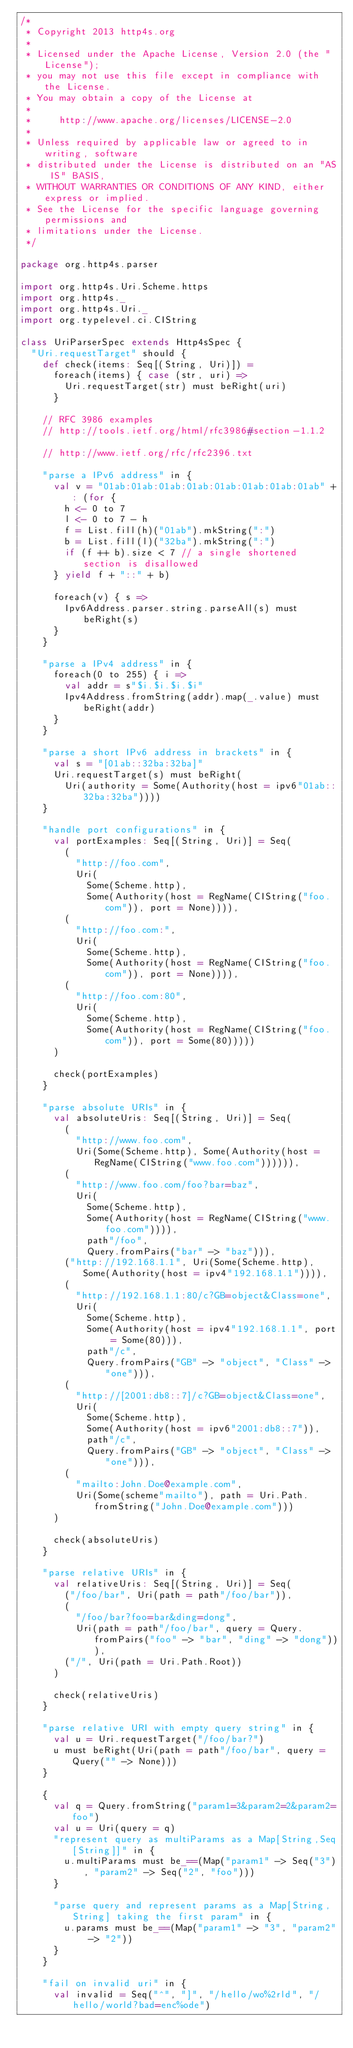<code> <loc_0><loc_0><loc_500><loc_500><_Scala_>/*
 * Copyright 2013 http4s.org
 *
 * Licensed under the Apache License, Version 2.0 (the "License");
 * you may not use this file except in compliance with the License.
 * You may obtain a copy of the License at
 *
 *     http://www.apache.org/licenses/LICENSE-2.0
 *
 * Unless required by applicable law or agreed to in writing, software
 * distributed under the License is distributed on an "AS IS" BASIS,
 * WITHOUT WARRANTIES OR CONDITIONS OF ANY KIND, either express or implied.
 * See the License for the specific language governing permissions and
 * limitations under the License.
 */

package org.http4s.parser

import org.http4s.Uri.Scheme.https
import org.http4s._
import org.http4s.Uri._
import org.typelevel.ci.CIString

class UriParserSpec extends Http4sSpec {
  "Uri.requestTarget" should {
    def check(items: Seq[(String, Uri)]) =
      foreach(items) { case (str, uri) =>
        Uri.requestTarget(str) must beRight(uri)
      }

    // RFC 3986 examples
    // http://tools.ietf.org/html/rfc3986#section-1.1.2

    // http://www.ietf.org/rfc/rfc2396.txt

    "parse a IPv6 address" in {
      val v = "01ab:01ab:01ab:01ab:01ab:01ab:01ab:01ab" +: (for {
        h <- 0 to 7
        l <- 0 to 7 - h
        f = List.fill(h)("01ab").mkString(":")
        b = List.fill(l)("32ba").mkString(":")
        if (f ++ b).size < 7 // a single shortened section is disallowed
      } yield f + "::" + b)

      foreach(v) { s =>
        Ipv6Address.parser.string.parseAll(s) must beRight(s)
      }
    }

    "parse a IPv4 address" in {
      foreach(0 to 255) { i =>
        val addr = s"$i.$i.$i.$i"
        Ipv4Address.fromString(addr).map(_.value) must beRight(addr)
      }
    }

    "parse a short IPv6 address in brackets" in {
      val s = "[01ab::32ba:32ba]"
      Uri.requestTarget(s) must beRight(
        Uri(authority = Some(Authority(host = ipv6"01ab::32ba:32ba"))))
    }

    "handle port configurations" in {
      val portExamples: Seq[(String, Uri)] = Seq(
        (
          "http://foo.com",
          Uri(
            Some(Scheme.http),
            Some(Authority(host = RegName(CIString("foo.com")), port = None)))),
        (
          "http://foo.com:",
          Uri(
            Some(Scheme.http),
            Some(Authority(host = RegName(CIString("foo.com")), port = None)))),
        (
          "http://foo.com:80",
          Uri(
            Some(Scheme.http),
            Some(Authority(host = RegName(CIString("foo.com")), port = Some(80)))))
      )

      check(portExamples)
    }

    "parse absolute URIs" in {
      val absoluteUris: Seq[(String, Uri)] = Seq(
        (
          "http://www.foo.com",
          Uri(Some(Scheme.http), Some(Authority(host = RegName(CIString("www.foo.com")))))),
        (
          "http://www.foo.com/foo?bar=baz",
          Uri(
            Some(Scheme.http),
            Some(Authority(host = RegName(CIString("www.foo.com")))),
            path"/foo",
            Query.fromPairs("bar" -> "baz"))),
        ("http://192.168.1.1", Uri(Some(Scheme.http), Some(Authority(host = ipv4"192.168.1.1")))),
        (
          "http://192.168.1.1:80/c?GB=object&Class=one",
          Uri(
            Some(Scheme.http),
            Some(Authority(host = ipv4"192.168.1.1", port = Some(80))),
            path"/c",
            Query.fromPairs("GB" -> "object", "Class" -> "one"))),
        (
          "http://[2001:db8::7]/c?GB=object&Class=one",
          Uri(
            Some(Scheme.http),
            Some(Authority(host = ipv6"2001:db8::7")),
            path"/c",
            Query.fromPairs("GB" -> "object", "Class" -> "one"))),
        (
          "mailto:John.Doe@example.com",
          Uri(Some(scheme"mailto"), path = Uri.Path.fromString("John.Doe@example.com")))
      )

      check(absoluteUris)
    }

    "parse relative URIs" in {
      val relativeUris: Seq[(String, Uri)] = Seq(
        ("/foo/bar", Uri(path = path"/foo/bar")),
        (
          "/foo/bar?foo=bar&ding=dong",
          Uri(path = path"/foo/bar", query = Query.fromPairs("foo" -> "bar", "ding" -> "dong"))),
        ("/", Uri(path = Uri.Path.Root))
      )

      check(relativeUris)
    }

    "parse relative URI with empty query string" in {
      val u = Uri.requestTarget("/foo/bar?")
      u must beRight(Uri(path = path"/foo/bar", query = Query("" -> None)))
    }

    {
      val q = Query.fromString("param1=3&param2=2&param2=foo")
      val u = Uri(query = q)
      "represent query as multiParams as a Map[String,Seq[String]]" in {
        u.multiParams must be_==(Map("param1" -> Seq("3"), "param2" -> Seq("2", "foo")))
      }

      "parse query and represent params as a Map[String,String] taking the first param" in {
        u.params must be_==(Map("param1" -> "3", "param2" -> "2"))
      }
    }

    "fail on invalid uri" in {
      val invalid = Seq("^", "]", "/hello/wo%2rld", "/hello/world?bad=enc%ode")</code> 